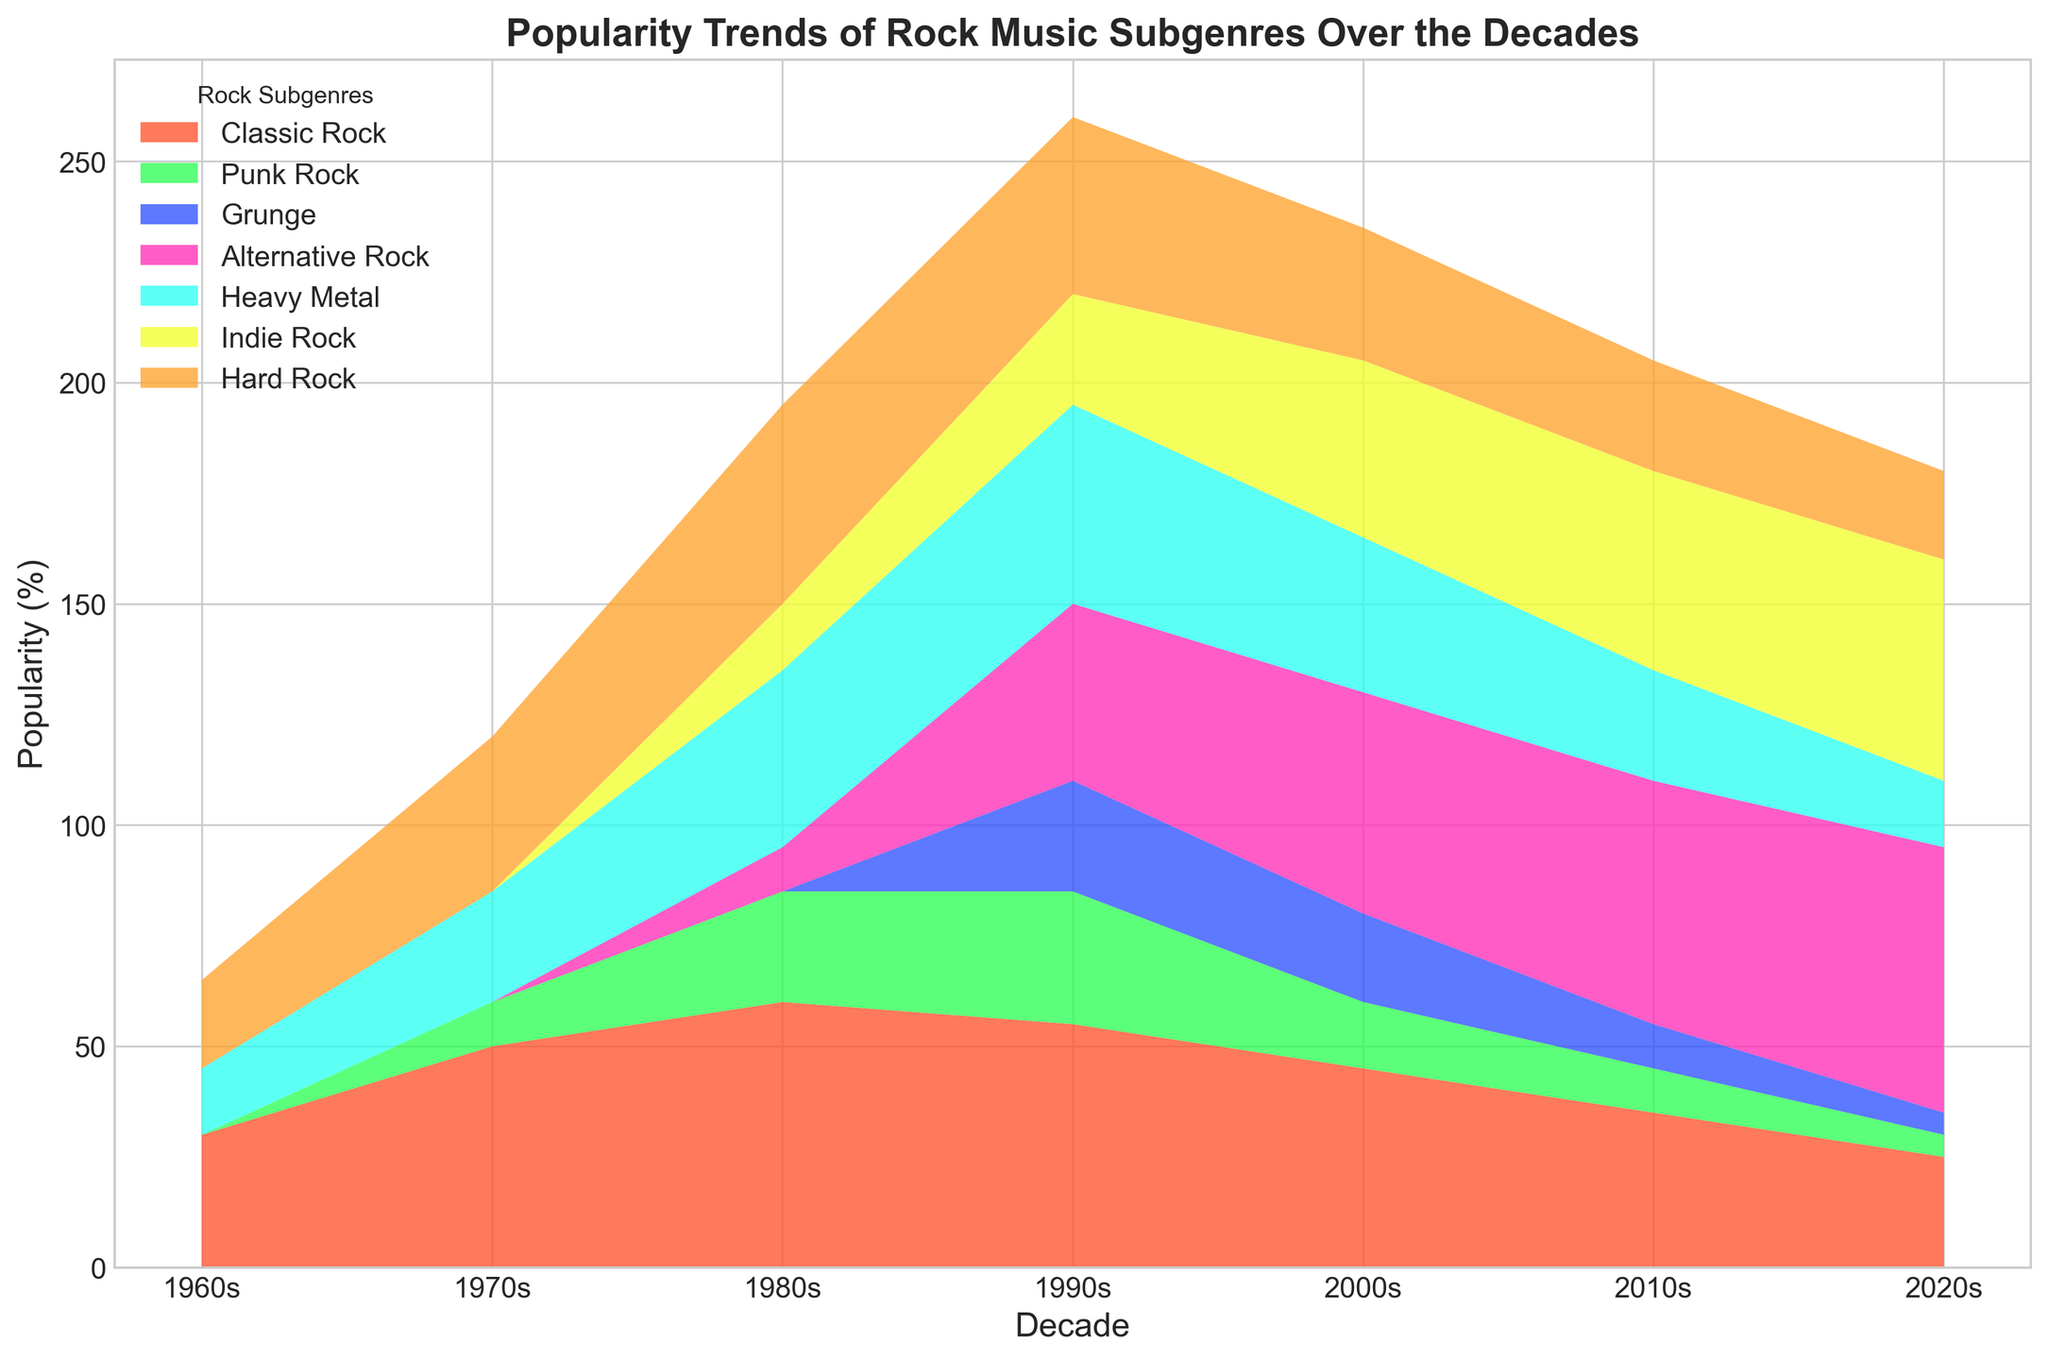what's the difference in popularity between Classic Rock and Heavy Metal in the 1980s? On the chart, locate the 1980s decade. Identify the segments for Classic Rock and Heavy Metal, noting their heights. The heights (popularity percentages) for Classic Rock and Heavy Metal in the 1980s are 60% and 40%, respectively. Calculating the difference gives 60% - 40% = 20%.
Answer: 20% Which subgenre has the highest popularity in the 2000s? Find the 2000s on the x-axis. Look at the height of the individual segments stacked for each subgenre. The highest segment (tallest height) corresponds to Alternative Rock at 50%.
Answer: Alternative Rock Which decade shows the highest overall popularity for Heavy Metal? Scan the Heavy Metal color segment across the decades. Compare the heights (popularity percentages) of the Heavy Metal segments. The 1990s show the highest Heavy Metal popularity at 45%.
Answer: 1990s How does the popularity of Indie Rock change from the 1990s to the 2020s? For both decades (1990s and 2020s), identify the Indie Rock segments and note their heights. The height for the 1990s is 25% and the 2020s is 50%. So, the change in popularity is from 25% to 50%, an increase of 25%.
Answer: Increase by 25% Which subgenres were not popular in the 1960s? Look at the 1960s section of the chart. Identify any segments with a height of 0%. The subgenres with 0% are Punk Rock, Grunge, Alternative Rock, and Indie Rock.
Answer: Punk Rock, Grunge, Alternative Rock, Indie Rock What's the sum of the popularity percentages for Classic Rock and Hard Rock in the 1990s? Find the 1990s on the x-axis. Locate both Classic Rock and Hard Rock segments and note their heights. Classic Rock is 55%, and Hard Rock is 40%. The sum is 55% + 40% = 95%.
Answer: 95% Compare the popularity trends of Alternative Rock and Heavy Metal from the 2000s to the 2020s. Which one has a greater increase? Observe the segments for Alternative Rock and Heavy Metal in both 2000s and 2020s. Alternative Rock: 2000s (50%) to 2020s (60%), an increase of 10%. Heavy Metal: 2000s (35%) to 2020s (15%), a decrease of 20%. Alternative Rock shows a greater increase.
Answer: Alternative Rock Which subgenre shows a decline in popularity from the 1980s to the 2020s? Look at the 1980s and 2020s segments for each subgenre.  Identify those with higher popularity in the 1980s than in the 2020s. Classic Rock declines from 60% to 25%, and several others show declines too, but Classic Rock has the evident decline.
Answer: Classic Rock 